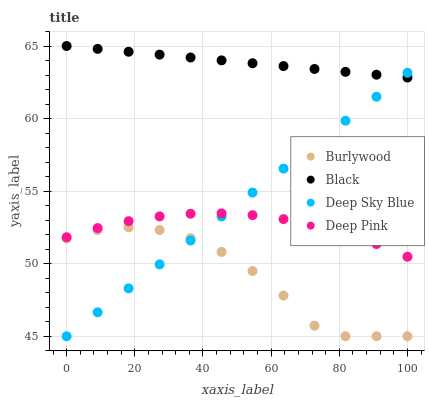Does Burlywood have the minimum area under the curve?
Answer yes or no. Yes. Does Black have the maximum area under the curve?
Answer yes or no. Yes. Does Deep Pink have the minimum area under the curve?
Answer yes or no. No. Does Deep Pink have the maximum area under the curve?
Answer yes or no. No. Is Deep Sky Blue the smoothest?
Answer yes or no. Yes. Is Burlywood the roughest?
Answer yes or no. Yes. Is Deep Pink the smoothest?
Answer yes or no. No. Is Deep Pink the roughest?
Answer yes or no. No. Does Burlywood have the lowest value?
Answer yes or no. Yes. Does Deep Pink have the lowest value?
Answer yes or no. No. Does Black have the highest value?
Answer yes or no. Yes. Does Deep Pink have the highest value?
Answer yes or no. No. Is Burlywood less than Black?
Answer yes or no. Yes. Is Black greater than Deep Pink?
Answer yes or no. Yes. Does Deep Sky Blue intersect Burlywood?
Answer yes or no. Yes. Is Deep Sky Blue less than Burlywood?
Answer yes or no. No. Is Deep Sky Blue greater than Burlywood?
Answer yes or no. No. Does Burlywood intersect Black?
Answer yes or no. No. 